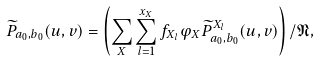Convert formula to latex. <formula><loc_0><loc_0><loc_500><loc_500>\widetilde { P } _ { a _ { 0 } , b _ { 0 } } ( u , v ) = \left ( \sum _ { X } \sum _ { l = 1 } ^ { x _ { X } } f _ { X _ { l } } \varphi _ { X } \widetilde { P } ^ { X _ { l } } _ { a _ { 0 } , b _ { 0 } } ( u , v ) \right ) / \mathfrak { N } ,</formula> 